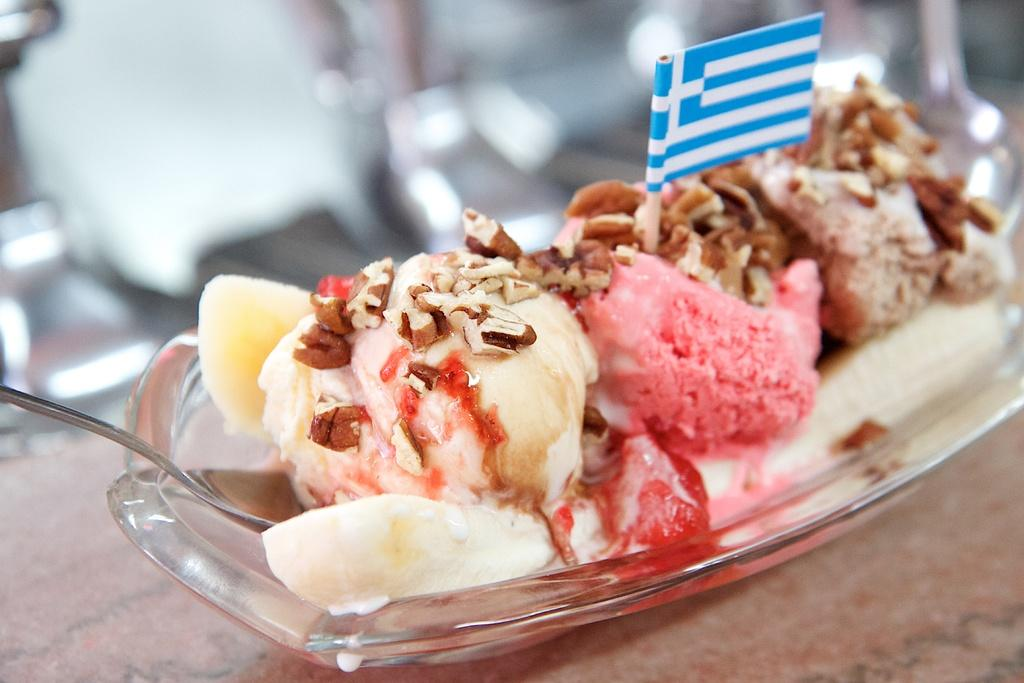What type of landscape is depicted in the image? There is a desert in the image. What utensil can be seen in the image? There is a spoon in the image. What is the spoon placed near in the image? There is a bowl in the image. Where is the bowl located in the image? The bowl is placed on a table. Can you see a dock near the seashore in the image? There is no dock or seashore present in the image; it features a desert landscape. 